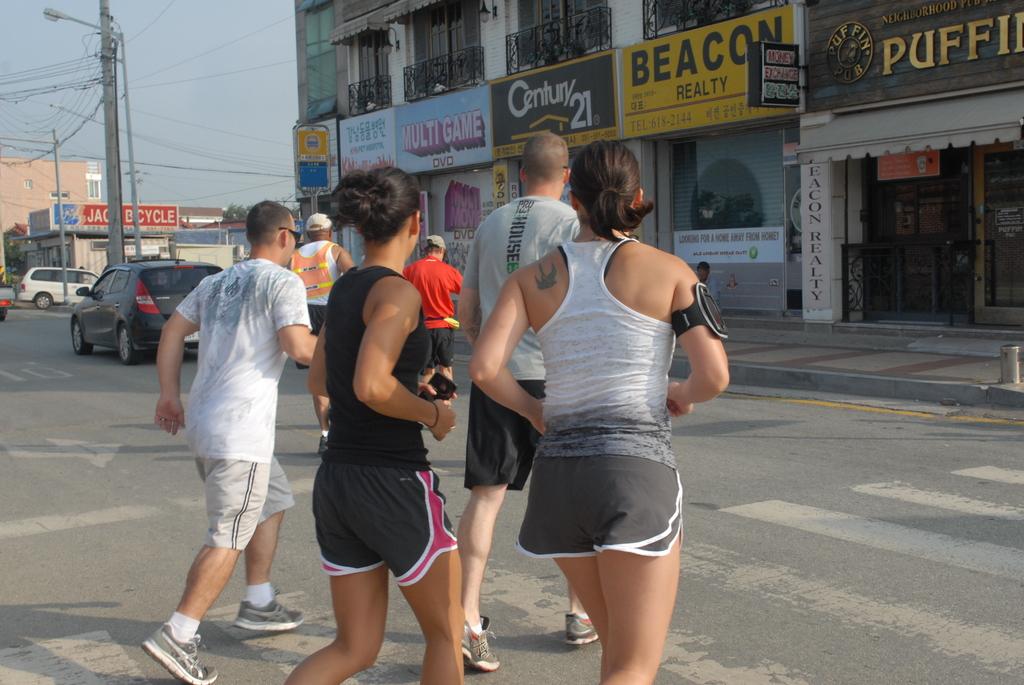What is the name of the realty store?
Offer a very short reply. Century 21. What real estate company is being advertised?
Provide a succinct answer. Century 21. 